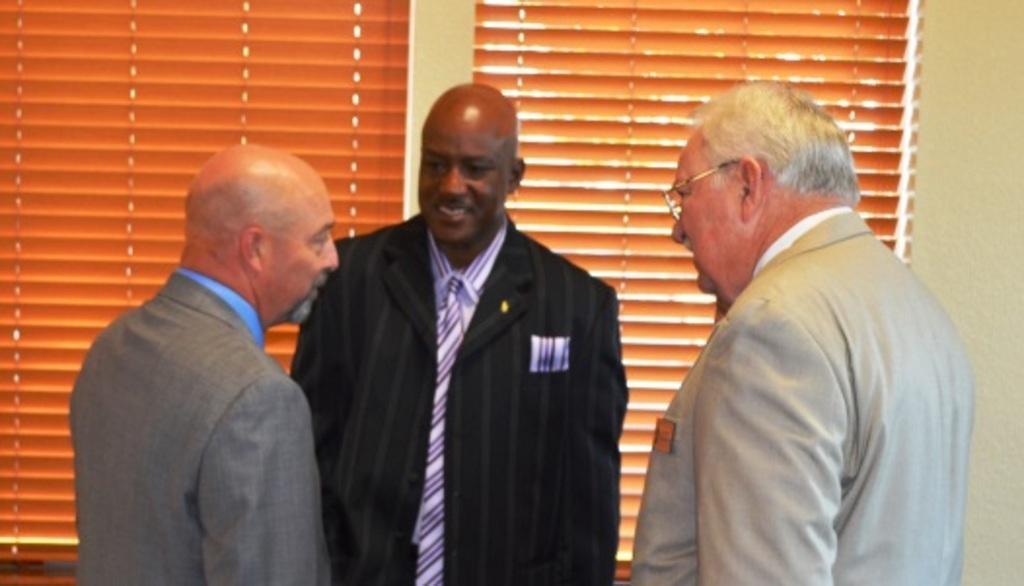How would you summarize this image in a sentence or two? In this image I can see three men and I can see they all are wearing formal dress. I can see smile on his face and here I can see he is wearing specs. In the background I can see brown colour window blinds. 